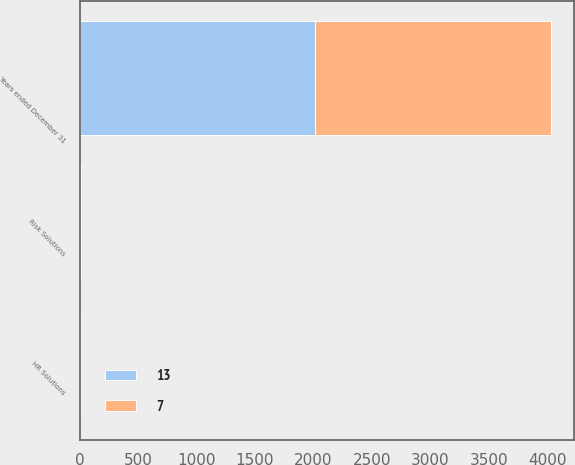Convert chart to OTSL. <chart><loc_0><loc_0><loc_500><loc_500><stacked_bar_chart><ecel><fcel>Years ended December 31<fcel>Risk Solutions<fcel>HR Solutions<nl><fcel>13<fcel>2015<fcel>4<fcel>3<nl><fcel>7<fcel>2014<fcel>11<fcel>2<nl></chart> 